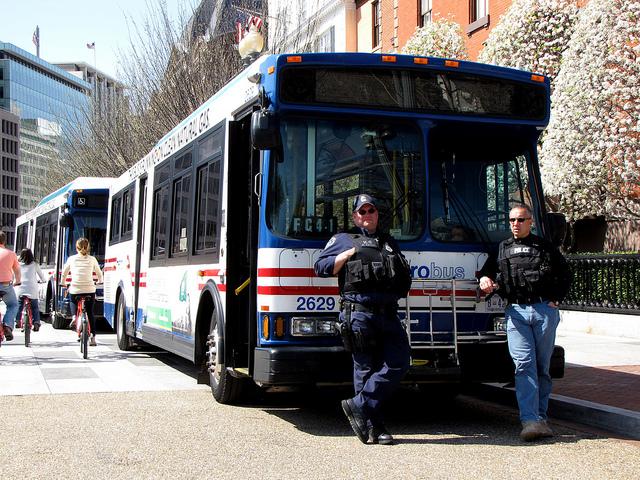Is the bus driver ready to get going?
Short answer required. No. How many people are riding bikes?
Give a very brief answer. 3. Are the police stopping the bus from falling over?
Be succinct. No. 